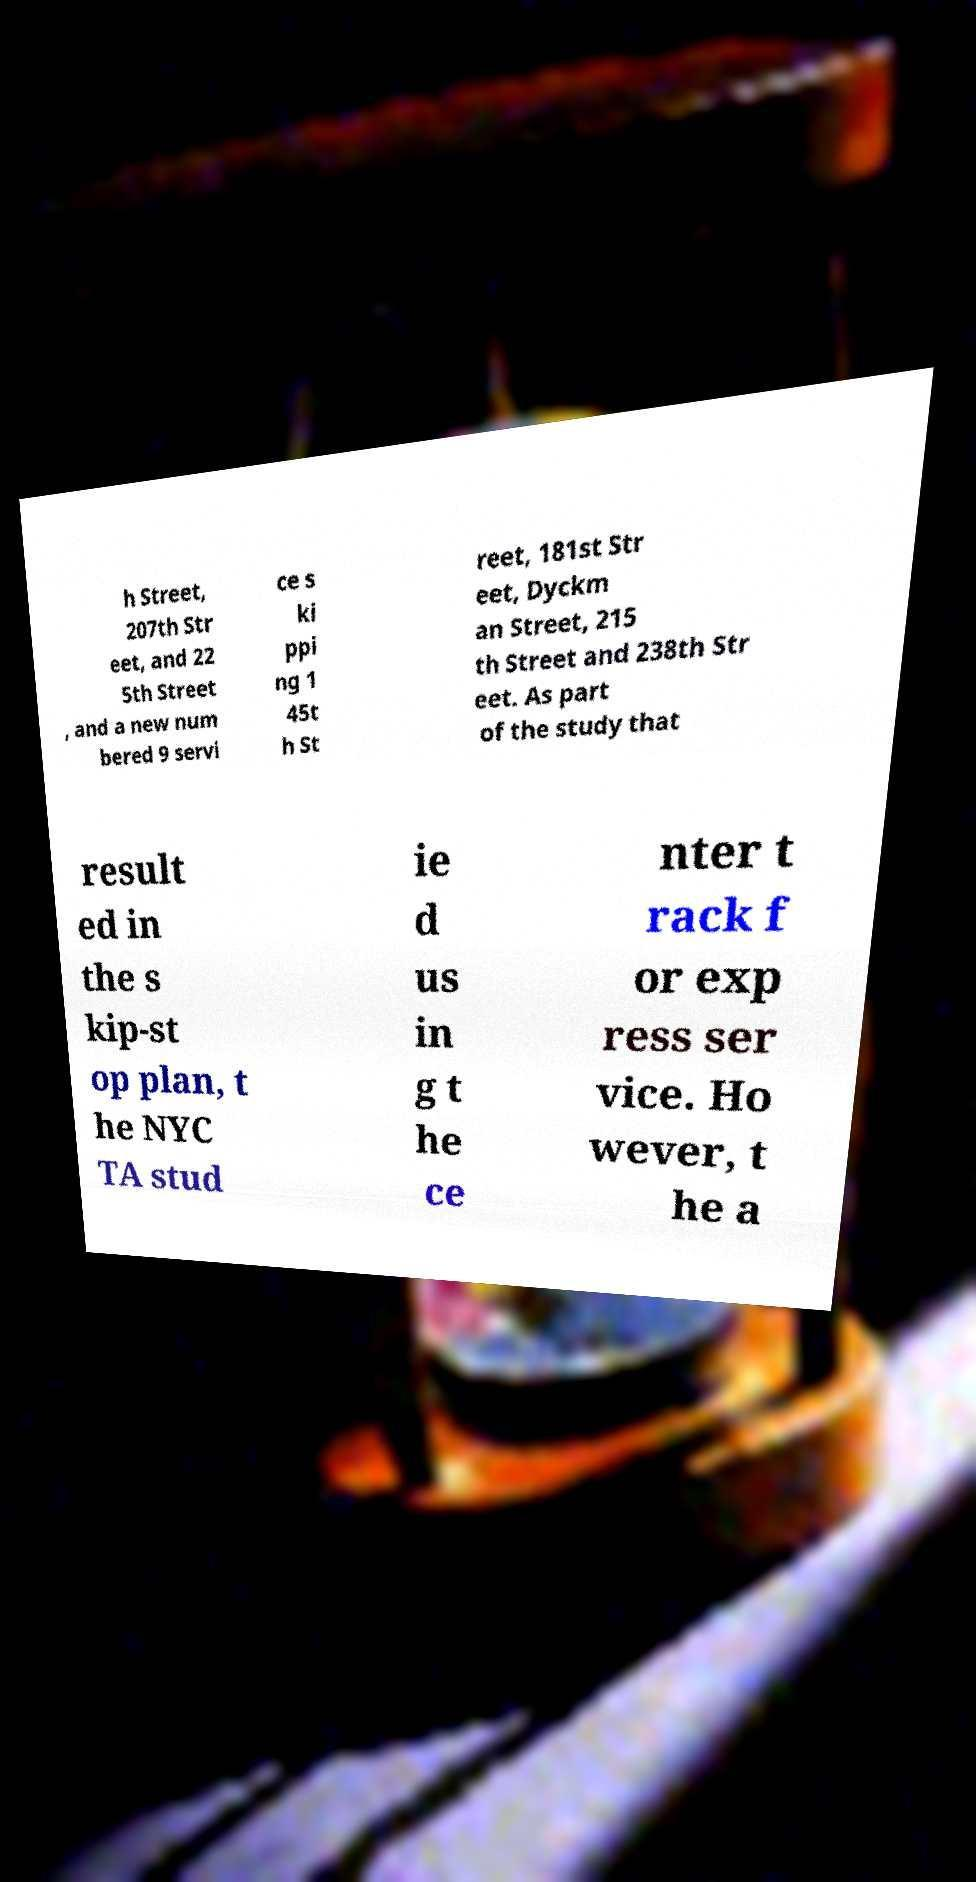Please read and relay the text visible in this image. What does it say? h Street, 207th Str eet, and 22 5th Street , and a new num bered 9 servi ce s ki ppi ng 1 45t h St reet, 181st Str eet, Dyckm an Street, 215 th Street and 238th Str eet. As part of the study that result ed in the s kip-st op plan, t he NYC TA stud ie d us in g t he ce nter t rack f or exp ress ser vice. Ho wever, t he a 